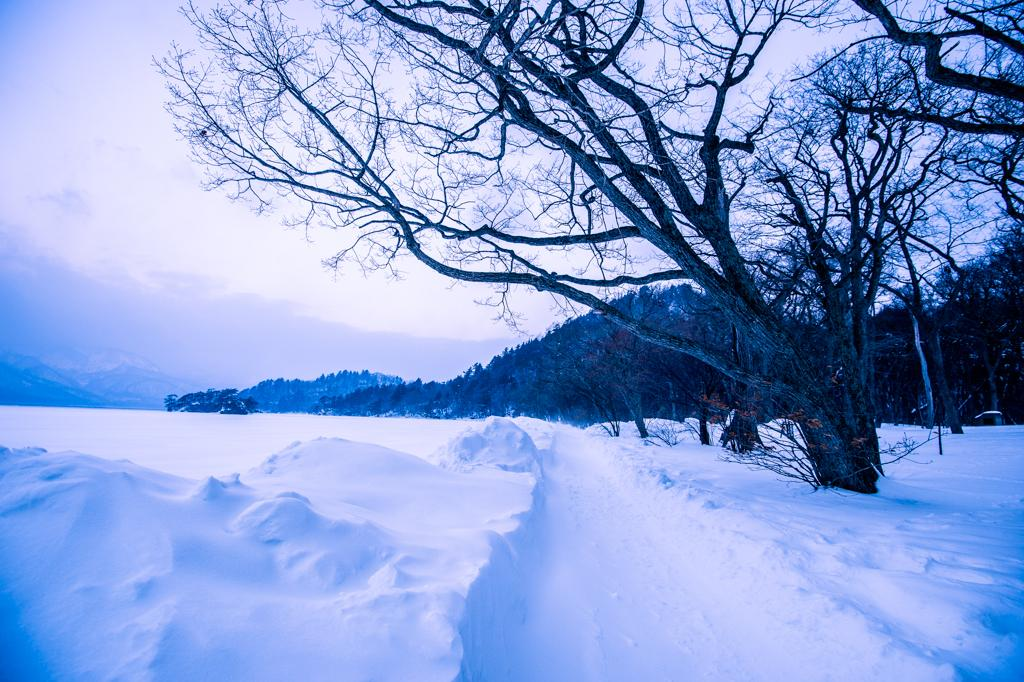What is covering the ground in the foreground of the image? There is snow on the ground in the foreground of the image. What can be seen in the background of the image? There are trees and hills in the background of the image. What is the condition of the sky in the image? The sky is cloudy in the image. What type of flowers can be seen growing in the snow in the image? There are no flowers visible in the image, as it features snow on the ground. 